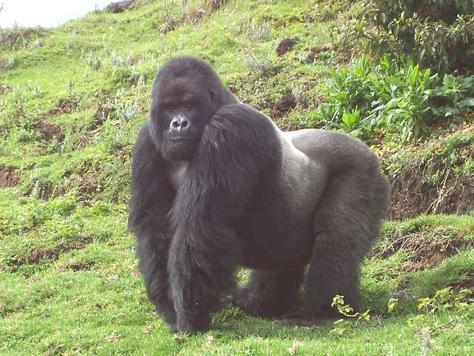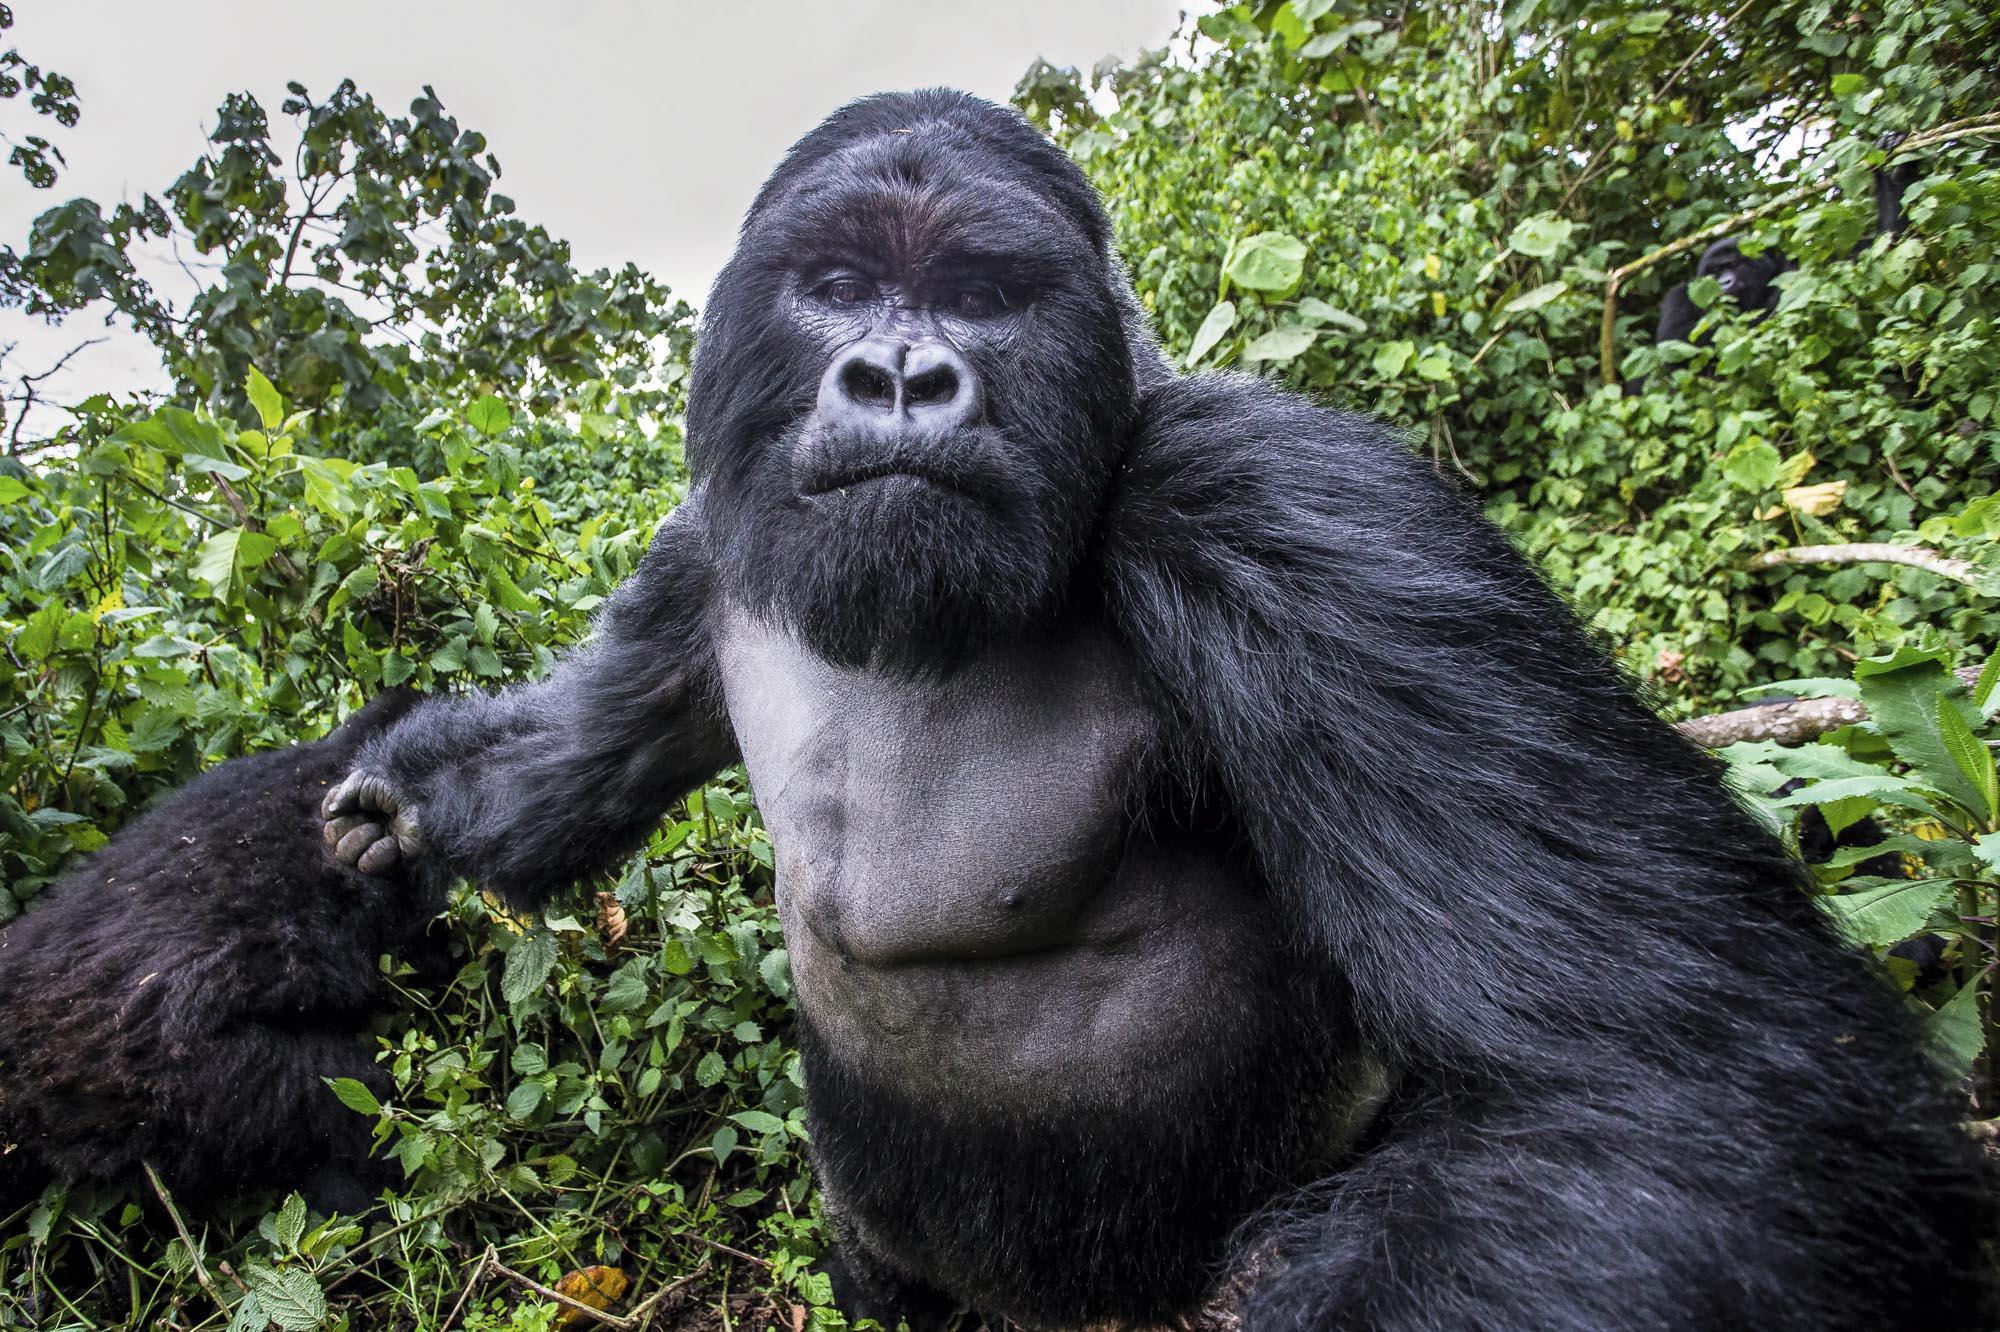The first image is the image on the left, the second image is the image on the right. Considering the images on both sides, is "The left image shows one adult gorilla on all fours, and the right image shows one adult gorilla with a frowning face looking directly at the camera." valid? Answer yes or no. Yes. The first image is the image on the left, the second image is the image on the right. Analyze the images presented: Is the assertion "There are two gorillas in one picture and one in the other." valid? Answer yes or no. Yes. 